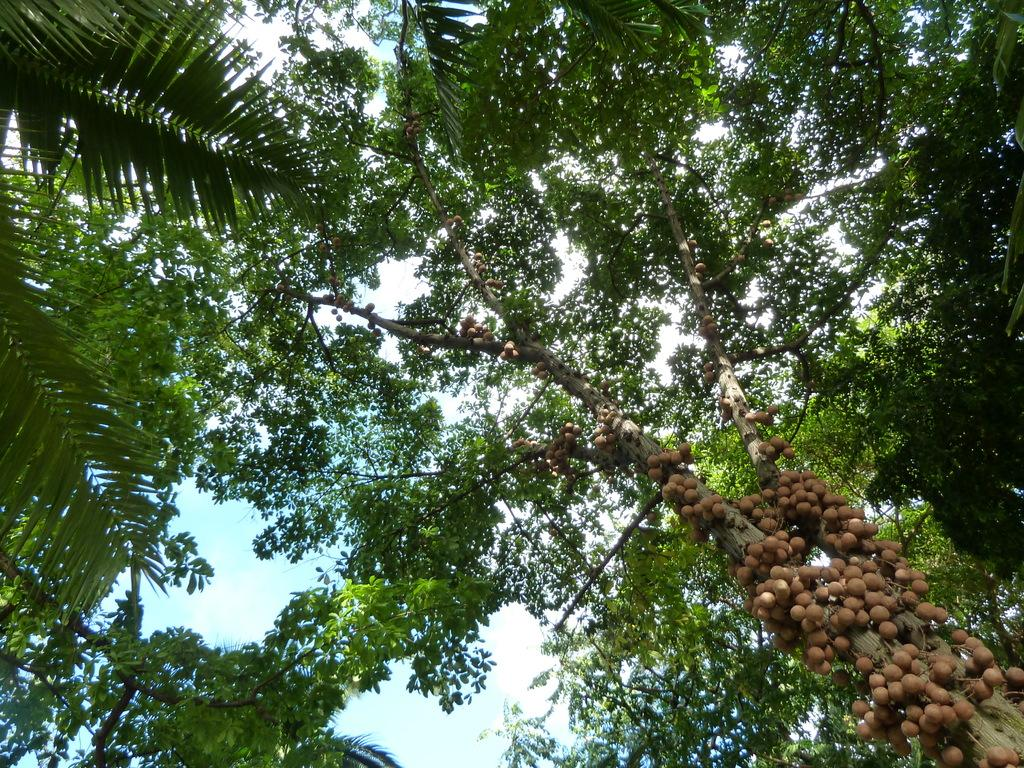What is located at the trunk of the tree in the image? There are fruits at the trunk of a tree in the image. What else can be seen in the image besides the tree with fruits? There are other trees visible in the image. What type of boot can be seen hanging from the tree in the image? There is no boot present in the image; it features fruits at the trunk of a tree and other trees in the background. 